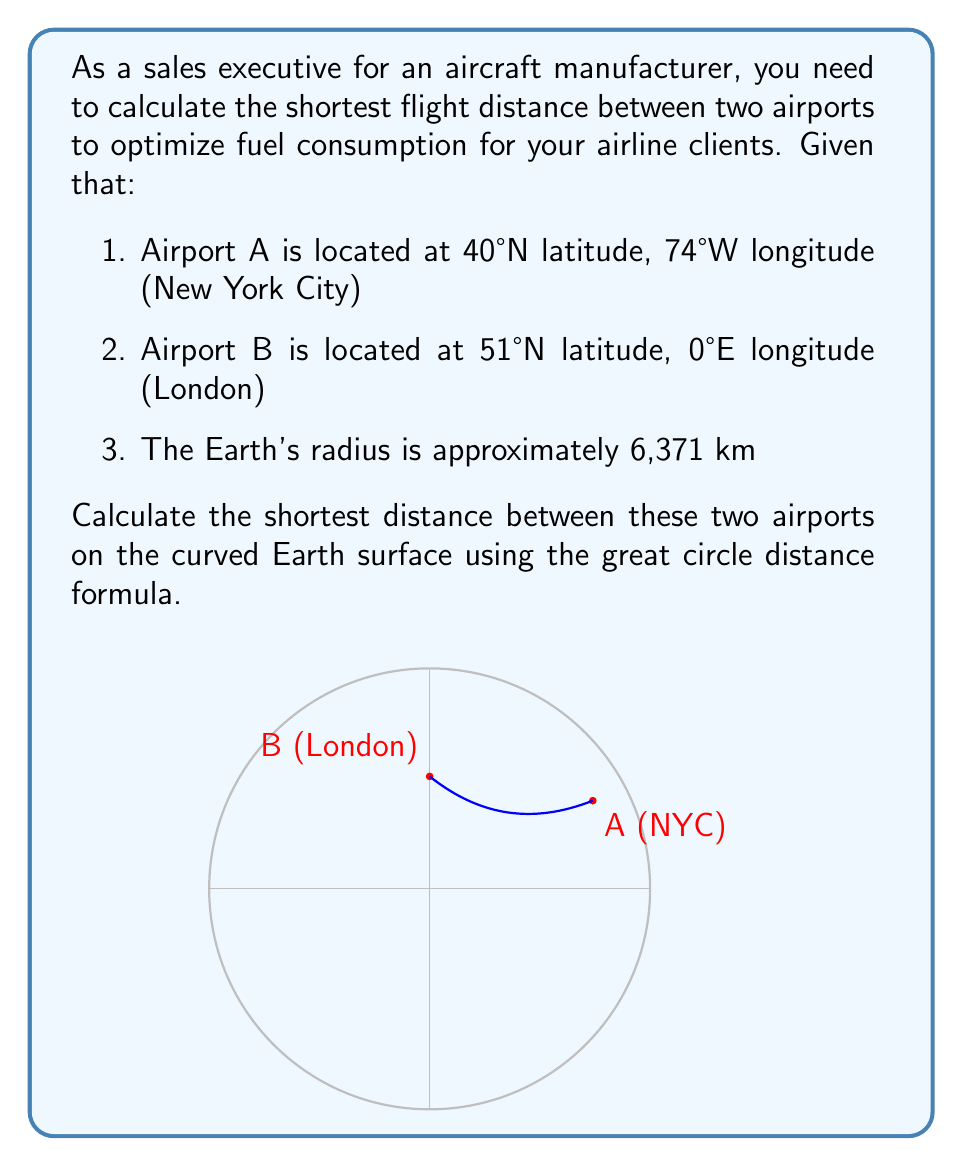Give your solution to this math problem. To solve this problem, we'll use the great circle distance formula, which calculates the shortest distance between two points on a sphere. The steps are as follows:

1. Convert the latitudes and longitudes from degrees to radians:
   $$\text{lat}_A = 40° \cdot \frac{\pi}{180} = 0.6981 \text{ rad}$$
   $$\text{lon}_A = -74° \cdot \frac{\pi}{180} = -1.2915 \text{ rad}$$
   $$\text{lat}_B = 51° \cdot \frac{\pi}{180} = 0.8901 \text{ rad}$$
   $$\text{lon}_B = 0° \cdot \frac{\pi}{180} = 0 \text{ rad}$$

2. Calculate the central angle $\Delta\sigma$ using the Haversine formula:
   $$\Delta\sigma = 2 \arcsin\left(\sqrt{\sin^2\left(\frac{\text{lat}_B - \text{lat}_A}{2}\right) + \cos(\text{lat}_A) \cos(\text{lat}_B) \sin^2\left(\frac{\text{lon}_B - \text{lon}_A}{2}\right)}\right)$$

3. Substitute the values:
   $$\Delta\sigma = 2 \arcsin\left(\sqrt{\sin^2\left(\frac{0.8901 - 0.6981}{2}\right) + \cos(0.6981) \cos(0.8901) \sin^2\left(\frac{0 - (-1.2915)}{2}\right)}\right)$$

4. Calculate the result:
   $$\Delta\sigma = 0.9880 \text{ rad}$$

5. Calculate the great circle distance by multiplying the central angle by the Earth's radius:
   $$d = R \cdot \Delta\sigma = 6371 \text{ km} \cdot 0.9880 \text{ rad} = 6292.37 \text{ km}$$

Therefore, the shortest distance between the two airports on the curved Earth surface is approximately 6292.37 km.
Answer: 6292.37 km 